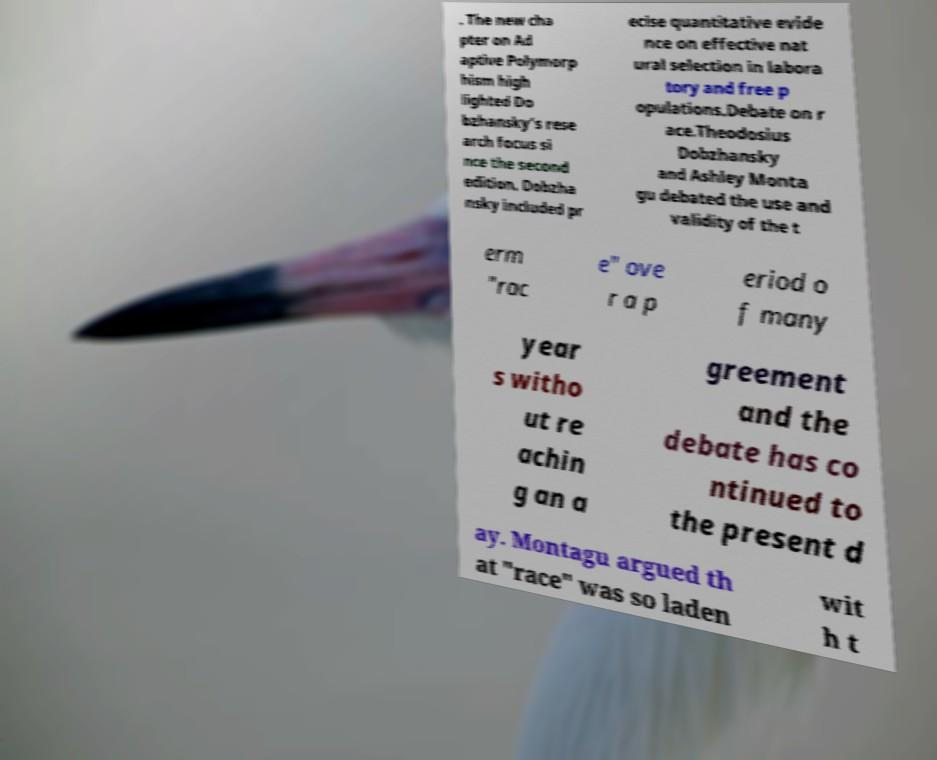Please identify and transcribe the text found in this image. . The new cha pter on Ad aptive Polymorp hism high lighted Do bzhansky’s rese arch focus si nce the second edition. Dobzha nsky included pr ecise quantitative evide nce on effective nat ural selection in labora tory and free p opulations.Debate on r ace.Theodosius Dobzhansky and Ashley Monta gu debated the use and validity of the t erm "rac e" ove r a p eriod o f many year s witho ut re achin g an a greement and the debate has co ntinued to the present d ay. Montagu argued th at "race" was so laden wit h t 